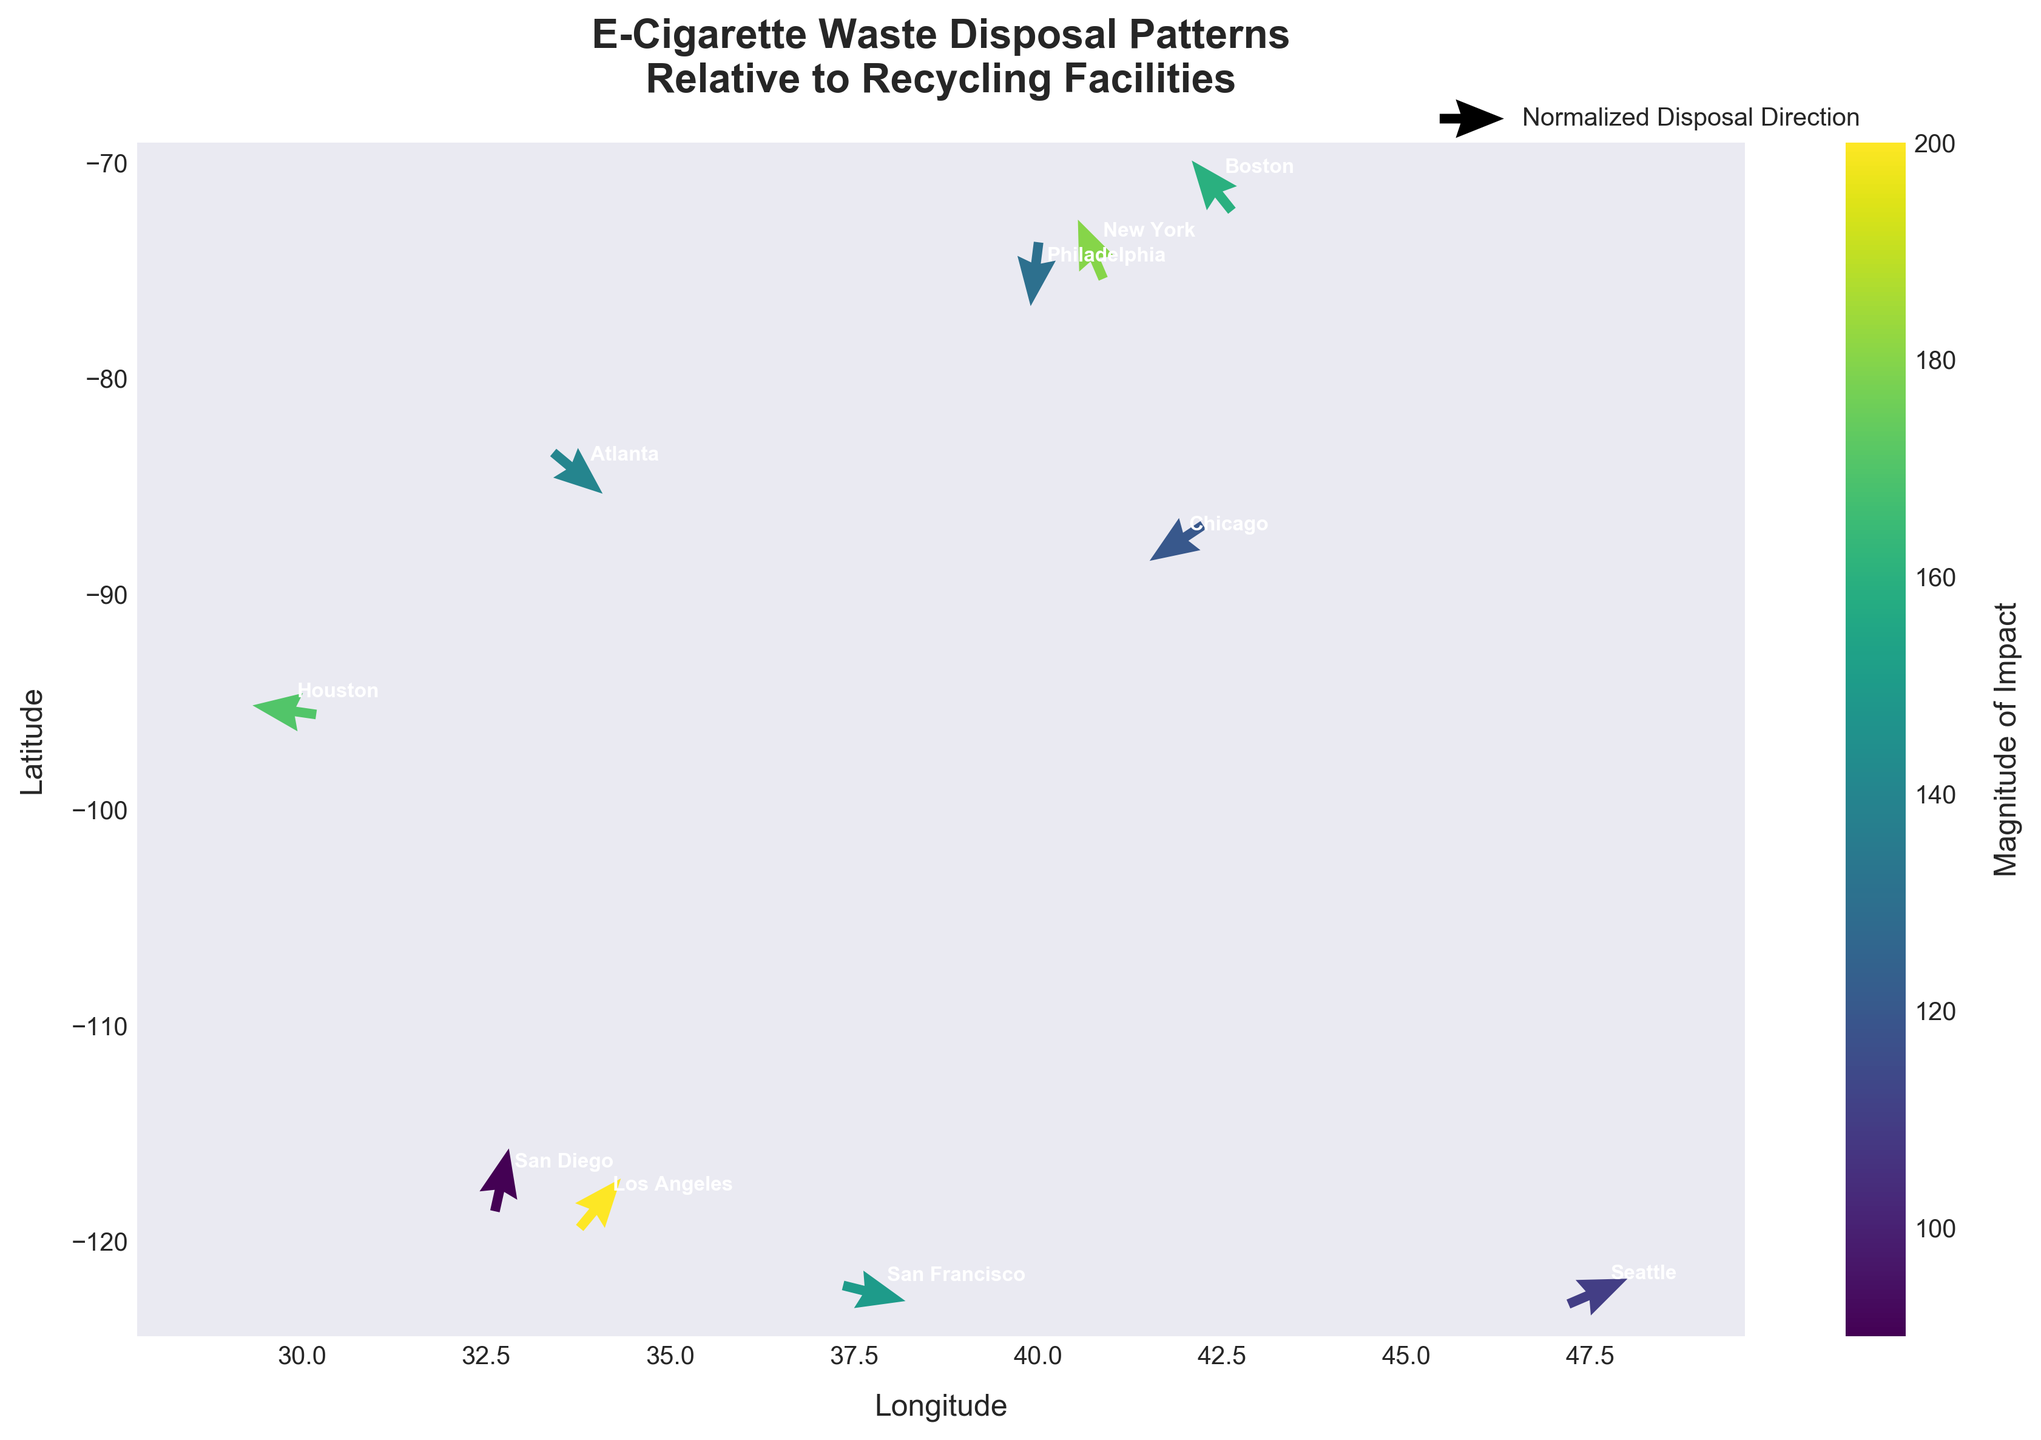What's the title of the figure? The title is written at the top of the figure. The text is: 'E-Cigarette Waste Disposal Patterns Relative to Recycling Facilities'.
Answer: E-Cigarette Waste Disposal Patterns Relative to Recycling Facilities How many cities are represented in the figure? There is an annotation for each city, labeling the data points. Count the number of annotations to get the total.
Answer: 10 Which city has the highest magnitude of impact? The color bar on the right indicates that darker colors correspond to higher magnitudes. By looking at the cities and their arrows, the darkest color is near 'Los Angeles'.
Answer: Los Angeles Which direction does the waste disposal pattern point in San Diego? To see the direction of the arrows, look at the coordinates for San Diego (32.7157, -117.1611). The arrow has a positive u component (right) and a positive v component (up).
Answer: Top-right Are there more cities with a positive u component than a negative one? Sum the number of cities with positive u components and compare it to those with negative u components. There are 6 positive and 4 negative.
Answer: Yes Which city has the steepest downward disposal direction? Focus on the v component values. The city with the most negative value corresponds to the steepest downward. Philadelphia has the most negative v value (-0.8).
Answer: Philadelphia Which cities have a similar direction of waste disposal pattern as New York? Check the direction of the arrow in New York (which has a negative u and positive v component) and identify other cities with a similar pattern (Chicago, Houston).
Answer: Chicago, Houston What is the average magnitude of impact across all cities? Sum the magnitudes and divide by the number of cities: (150 + 200 + 180 + 120 + 90 + 130 + 110 + 160 + 140 + 170) / 10 = 145.
Answer: 145 Which city exhibits the least impact (lowest magnitude)? The color bar helps determine magnitude. The lightest arrow color, which indicates the smallest magnitude, is associated with San Diego.
Answer: San Diego 